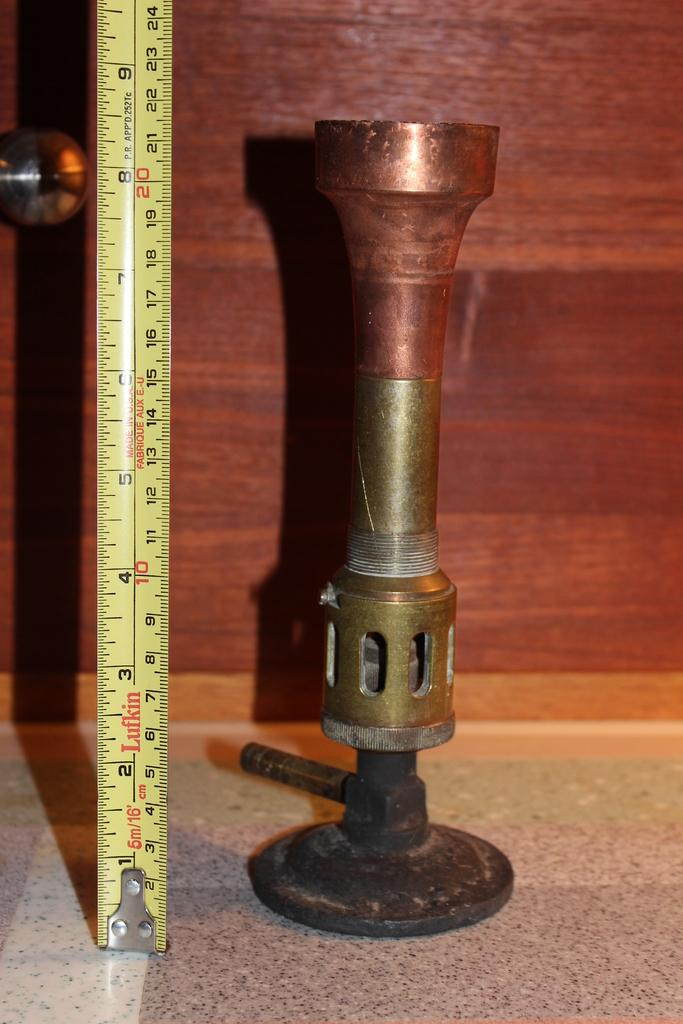<image>
Write a terse but informative summary of the picture. A nine inch piece of metal sits on a table. 